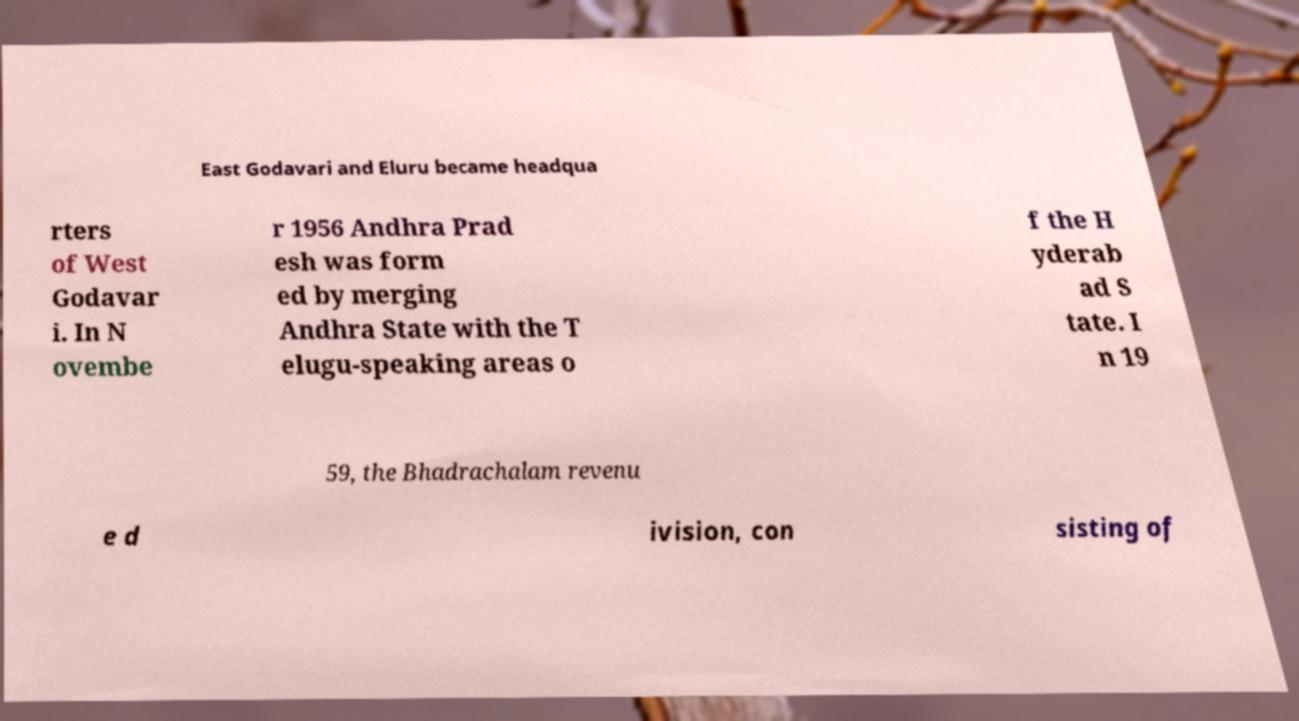Could you extract and type out the text from this image? East Godavari and Eluru became headqua rters of West Godavar i. In N ovembe r 1956 Andhra Prad esh was form ed by merging Andhra State with the T elugu-speaking areas o f the H yderab ad S tate. I n 19 59, the Bhadrachalam revenu e d ivision, con sisting of 